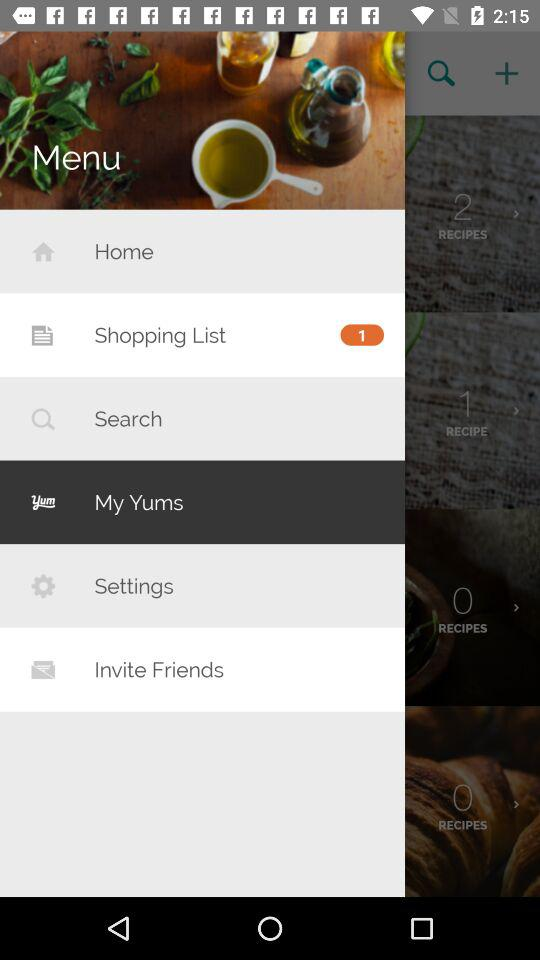Which tab is selected? The selected tab is "My Yums". 